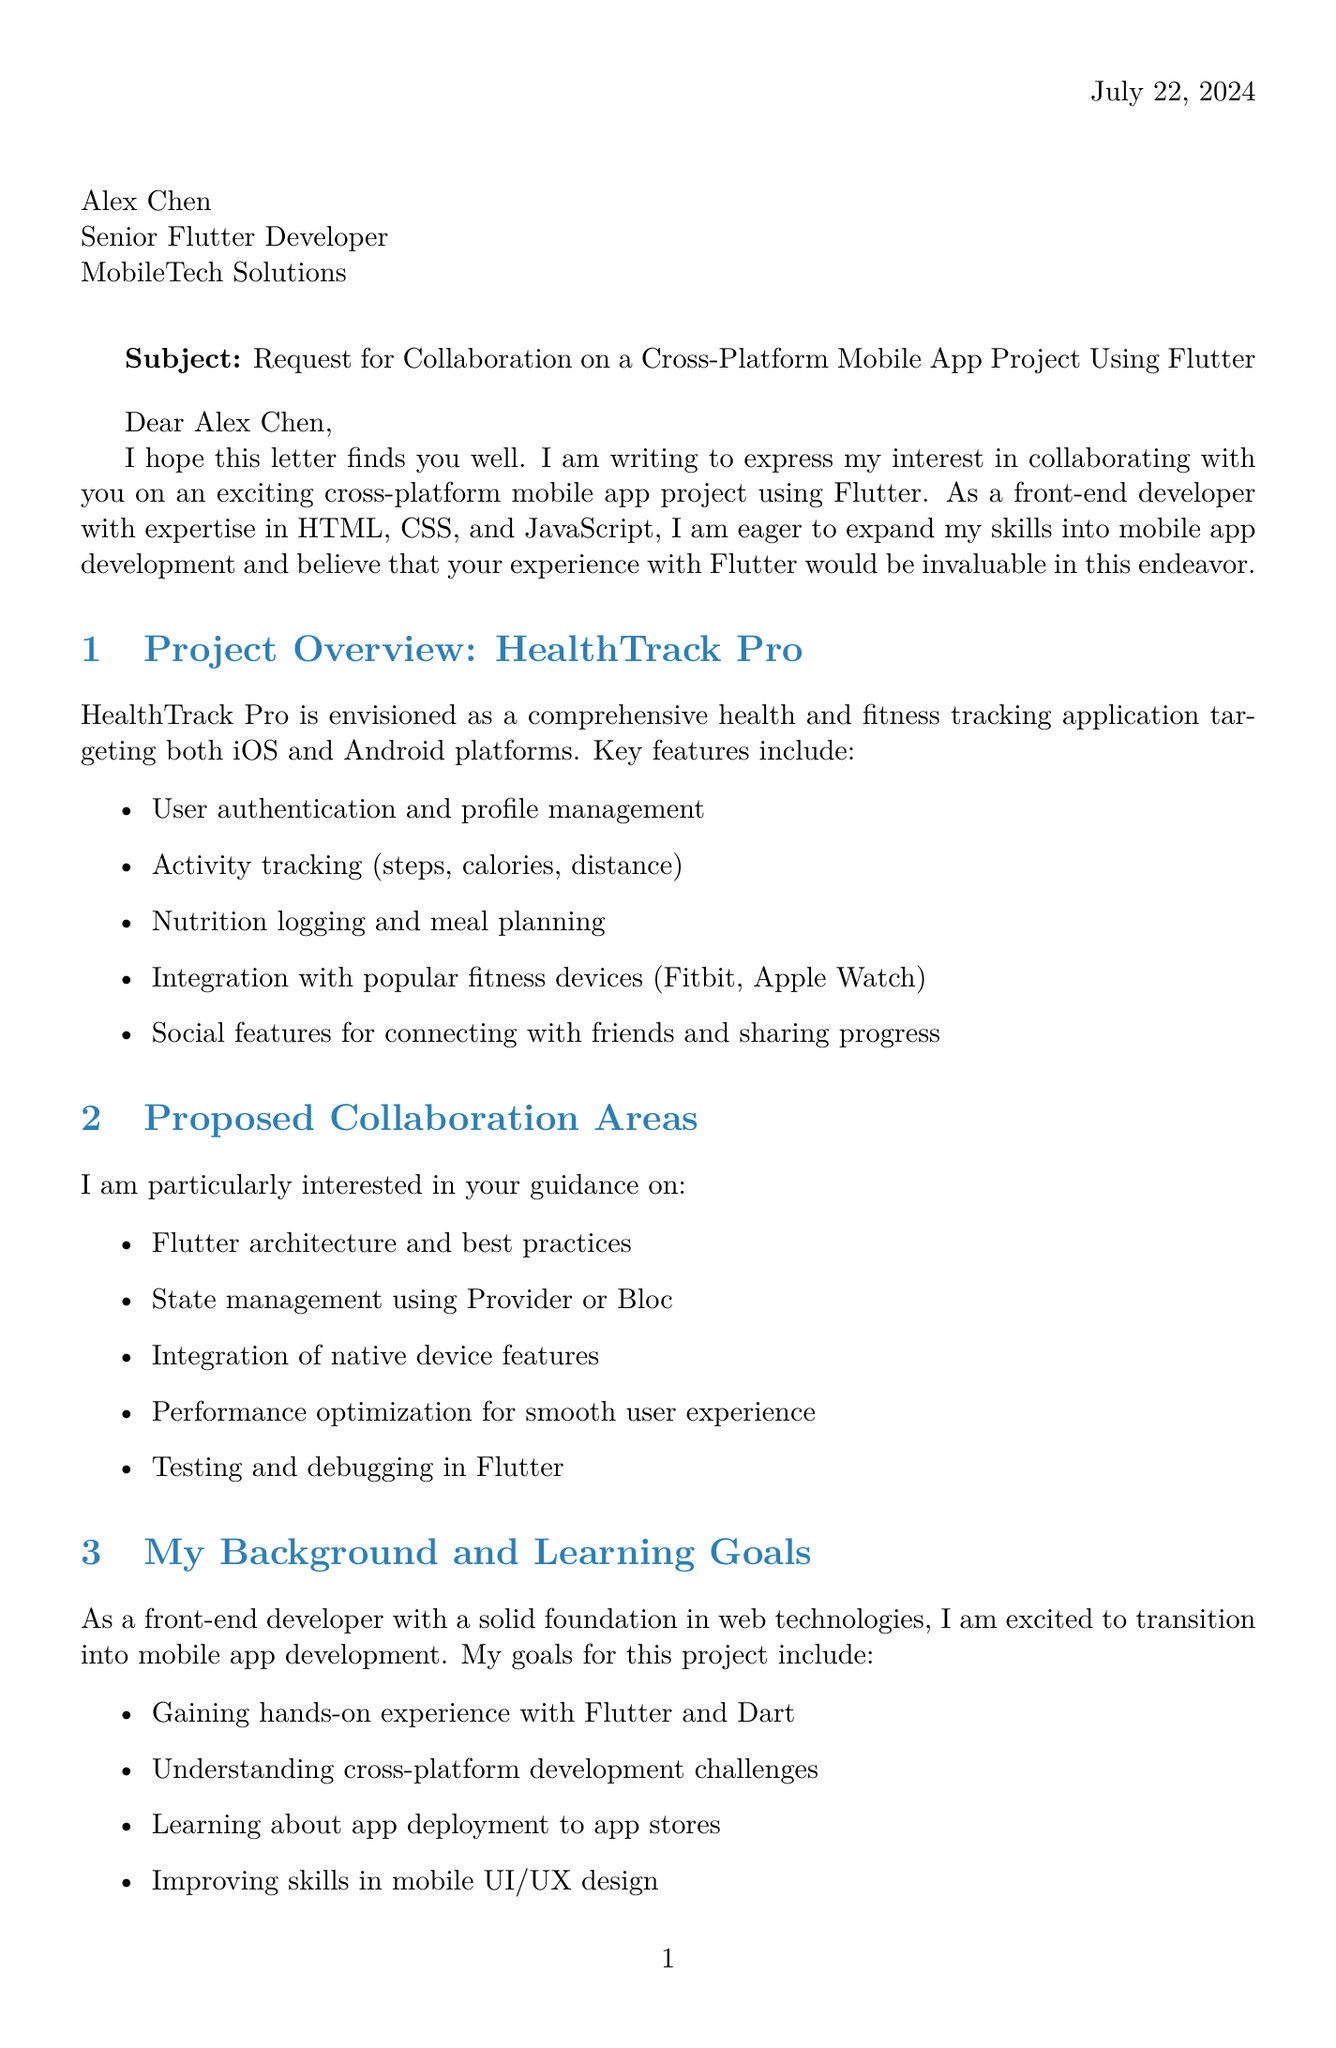What is the name of the proposed app? The document specifies that the proposed app is named "HealthTrack Pro."
Answer: HealthTrack Pro Who is the recipient of the letter? The letter is addressed to Alex Chen, who is the Senior Flutter Developer at MobileTech Solutions.
Answer: Alex Chen How long is the proposed project duration? The document states that the proposed project duration is 3 months.
Answer: 3 months What platform will the app target? According to the document, the app will target both iOS and Android platforms.
Answer: iOS and Android What is one of the key features of the app? The document lists several key features, one of which is activity tracking (steps, calories, distance).
Answer: Activity tracking (steps, calories, distance) What are the learning goals mentioned? One of the learning goals mentioned is gaining hands-on experience with Flutter and Dart.
Answer: Gaining hands-on experience with Flutter and Dart What is a potential challenge highlighted in the document? One potential challenge noted is the learning curve for Flutter and Dart.
Answer: Learning curve for Flutter and Dart What is the first milestone in the proposed timeline? The first milestone in the proposed timeline is project setup and initial UI development.
Answer: Project setup and initial UI development What programming language is used in the technical stack? The programming language specified in the technical stack is Dart.
Answer: Dart 